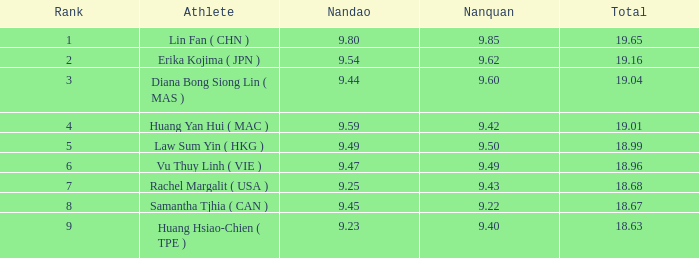Which nanquan has a nandao with a size surpassing 9.49 and a 4th rank? 9.42. 